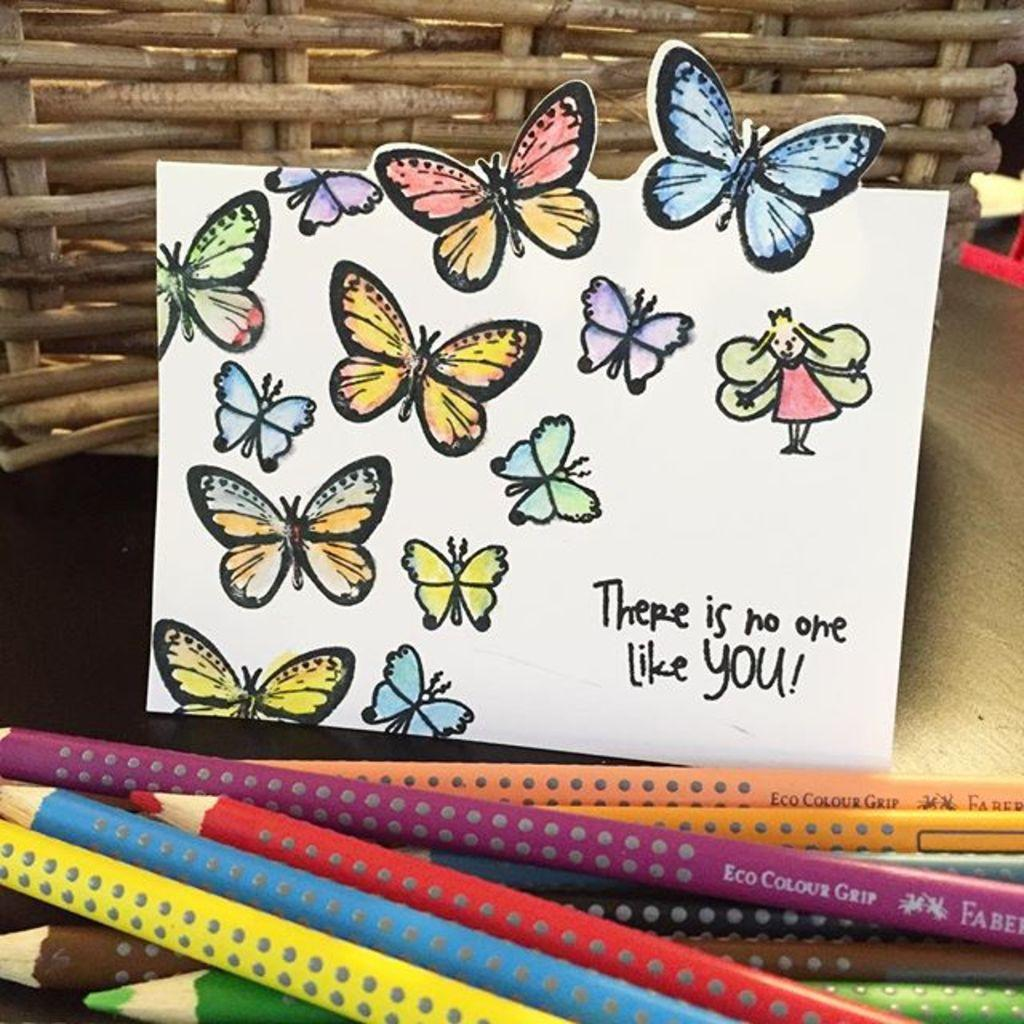What object can be seen in the image that is typically used for carrying items? There is a basket in the image that is typically used for carrying items. What type of wall decoration is present in the image? There is a poster in the image that serves as wall decoration. What stationery item can be seen in the image? There are color pencils in the image. What type of lettuce is featured in the poster in the image? There is no lettuce present in the image, as the poster does not depict any food items. 